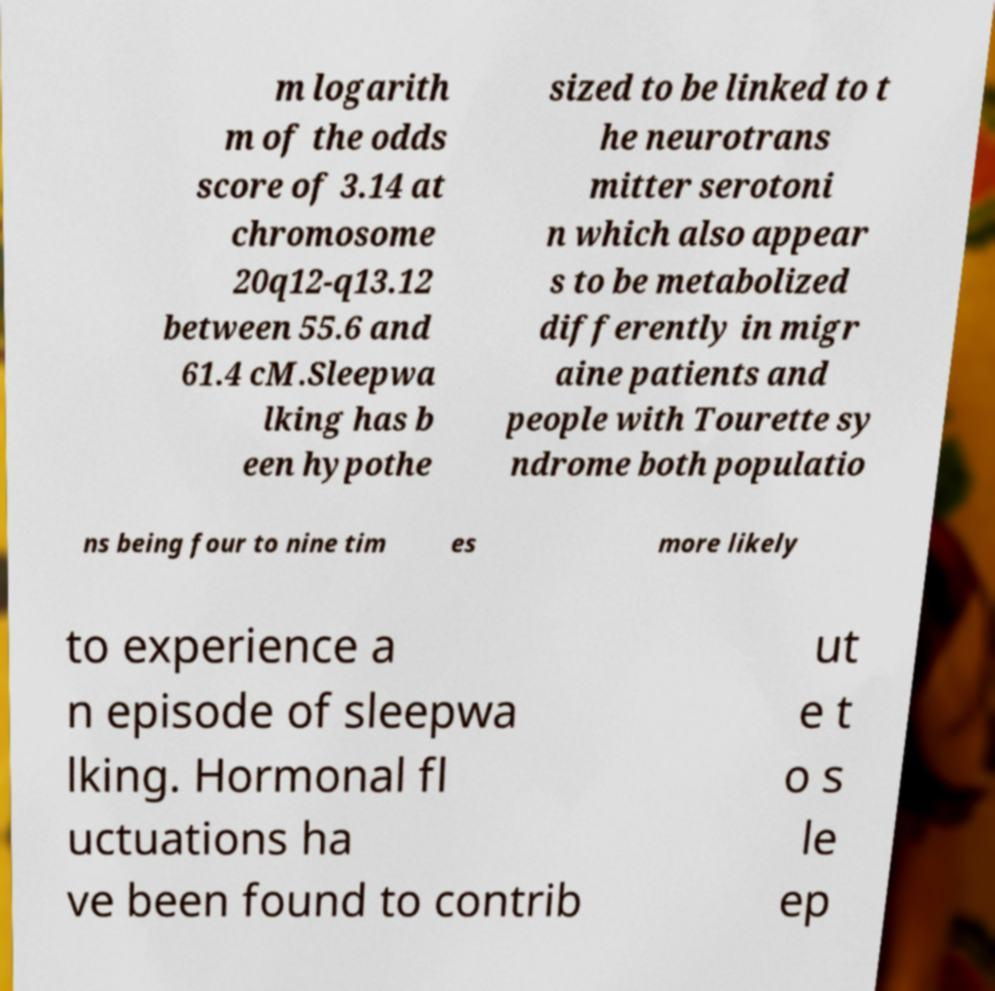Can you accurately transcribe the text from the provided image for me? m logarith m of the odds score of 3.14 at chromosome 20q12-q13.12 between 55.6 and 61.4 cM.Sleepwa lking has b een hypothe sized to be linked to t he neurotrans mitter serotoni n which also appear s to be metabolized differently in migr aine patients and people with Tourette sy ndrome both populatio ns being four to nine tim es more likely to experience a n episode of sleepwa lking. Hormonal fl uctuations ha ve been found to contrib ut e t o s le ep 